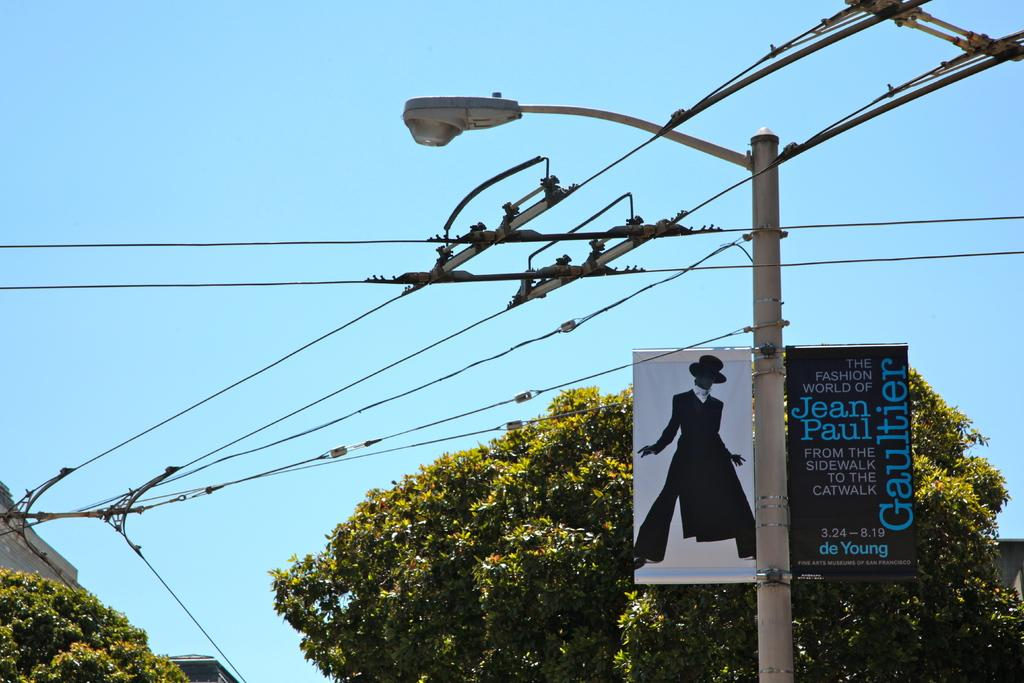What type of infrastructure can be seen in the image? There are electrical lines in the image. What is attached to the pole in the image? There is a light and hoardings attached to the pole in the image. What is the location of the pole in the image? The pole is near a tree in the image. What can be seen in the background of the image? There is a building and a tree in the background of the image. What is the color of the sky in the background of the image? The sky is blue in the background of the image. What is the name of the zebra standing near the tree in the image? There is no zebra present in the image. What is the zebra using to collect water from the bucket in the image? There is no zebra or bucket present in the image. 